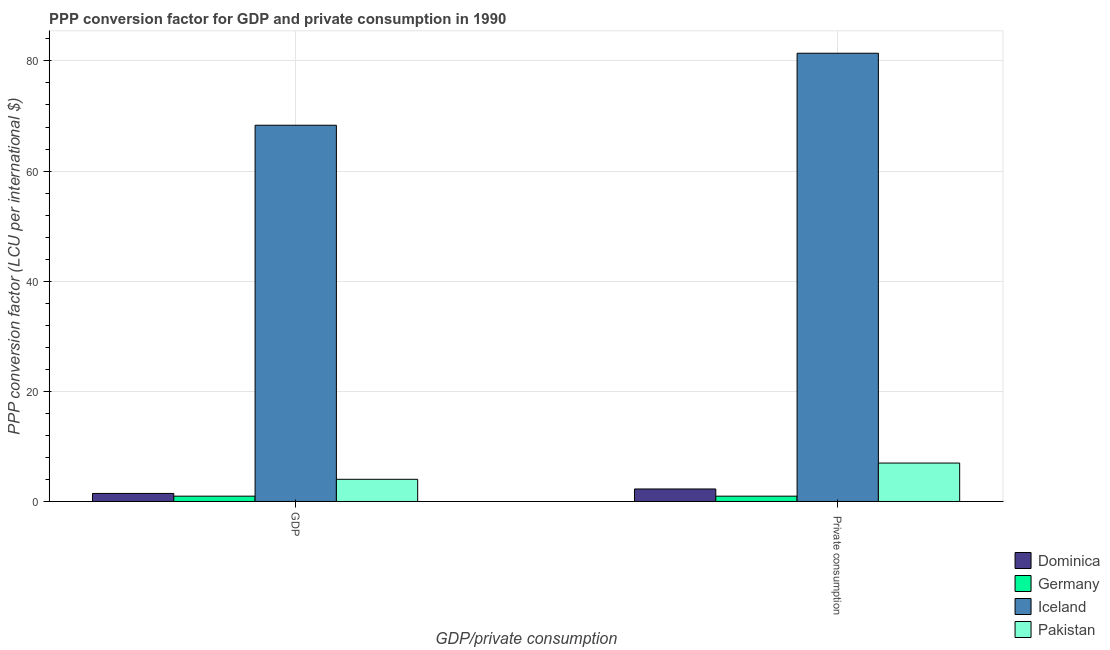How many groups of bars are there?
Keep it short and to the point. 2. What is the label of the 1st group of bars from the left?
Keep it short and to the point. GDP. What is the ppp conversion factor for gdp in Dominica?
Provide a short and direct response. 1.46. Across all countries, what is the maximum ppp conversion factor for gdp?
Ensure brevity in your answer.  68.32. Across all countries, what is the minimum ppp conversion factor for gdp?
Your response must be concise. 0.96. In which country was the ppp conversion factor for gdp maximum?
Offer a terse response. Iceland. In which country was the ppp conversion factor for private consumption minimum?
Ensure brevity in your answer.  Germany. What is the total ppp conversion factor for private consumption in the graph?
Give a very brief answer. 91.61. What is the difference between the ppp conversion factor for private consumption in Germany and that in Iceland?
Give a very brief answer. -80.43. What is the difference between the ppp conversion factor for gdp in Iceland and the ppp conversion factor for private consumption in Pakistan?
Ensure brevity in your answer.  61.34. What is the average ppp conversion factor for gdp per country?
Give a very brief answer. 18.69. What is the difference between the ppp conversion factor for gdp and ppp conversion factor for private consumption in Dominica?
Your answer should be compact. -0.81. What is the ratio of the ppp conversion factor for private consumption in Dominica to that in Iceland?
Provide a short and direct response. 0.03. Is the ppp conversion factor for gdp in Germany less than that in Pakistan?
Provide a short and direct response. Yes. What does the 3rd bar from the left in  Private consumption represents?
Your answer should be very brief. Iceland. How many countries are there in the graph?
Make the answer very short. 4. Does the graph contain any zero values?
Ensure brevity in your answer.  No. How many legend labels are there?
Your answer should be very brief. 4. How are the legend labels stacked?
Provide a short and direct response. Vertical. What is the title of the graph?
Make the answer very short. PPP conversion factor for GDP and private consumption in 1990. What is the label or title of the X-axis?
Your response must be concise. GDP/private consumption. What is the label or title of the Y-axis?
Ensure brevity in your answer.  PPP conversion factor (LCU per international $). What is the PPP conversion factor (LCU per international $) in Dominica in GDP?
Keep it short and to the point. 1.46. What is the PPP conversion factor (LCU per international $) of Germany in GDP?
Provide a short and direct response. 0.96. What is the PPP conversion factor (LCU per international $) of Iceland in GDP?
Keep it short and to the point. 68.32. What is the PPP conversion factor (LCU per international $) of Pakistan in GDP?
Make the answer very short. 4.03. What is the PPP conversion factor (LCU per international $) of Dominica in  Private consumption?
Give a very brief answer. 2.27. What is the PPP conversion factor (LCU per international $) of Germany in  Private consumption?
Your answer should be compact. 0.96. What is the PPP conversion factor (LCU per international $) of Iceland in  Private consumption?
Keep it short and to the point. 81.4. What is the PPP conversion factor (LCU per international $) in Pakistan in  Private consumption?
Make the answer very short. 6.98. Across all GDP/private consumption, what is the maximum PPP conversion factor (LCU per international $) of Dominica?
Offer a terse response. 2.27. Across all GDP/private consumption, what is the maximum PPP conversion factor (LCU per international $) of Germany?
Offer a very short reply. 0.96. Across all GDP/private consumption, what is the maximum PPP conversion factor (LCU per international $) of Iceland?
Offer a very short reply. 81.4. Across all GDP/private consumption, what is the maximum PPP conversion factor (LCU per international $) in Pakistan?
Make the answer very short. 6.98. Across all GDP/private consumption, what is the minimum PPP conversion factor (LCU per international $) in Dominica?
Ensure brevity in your answer.  1.46. Across all GDP/private consumption, what is the minimum PPP conversion factor (LCU per international $) of Germany?
Make the answer very short. 0.96. Across all GDP/private consumption, what is the minimum PPP conversion factor (LCU per international $) of Iceland?
Offer a very short reply. 68.32. Across all GDP/private consumption, what is the minimum PPP conversion factor (LCU per international $) of Pakistan?
Provide a succinct answer. 4.03. What is the total PPP conversion factor (LCU per international $) of Dominica in the graph?
Keep it short and to the point. 3.73. What is the total PPP conversion factor (LCU per international $) of Germany in the graph?
Give a very brief answer. 1.93. What is the total PPP conversion factor (LCU per international $) in Iceland in the graph?
Make the answer very short. 149.72. What is the total PPP conversion factor (LCU per international $) in Pakistan in the graph?
Keep it short and to the point. 11. What is the difference between the PPP conversion factor (LCU per international $) in Dominica in GDP and that in  Private consumption?
Your answer should be compact. -0.81. What is the difference between the PPP conversion factor (LCU per international $) of Germany in GDP and that in  Private consumption?
Give a very brief answer. -0. What is the difference between the PPP conversion factor (LCU per international $) in Iceland in GDP and that in  Private consumption?
Provide a short and direct response. -13.08. What is the difference between the PPP conversion factor (LCU per international $) of Pakistan in GDP and that in  Private consumption?
Provide a short and direct response. -2.95. What is the difference between the PPP conversion factor (LCU per international $) in Dominica in GDP and the PPP conversion factor (LCU per international $) in Germany in  Private consumption?
Ensure brevity in your answer.  0.49. What is the difference between the PPP conversion factor (LCU per international $) of Dominica in GDP and the PPP conversion factor (LCU per international $) of Iceland in  Private consumption?
Give a very brief answer. -79.94. What is the difference between the PPP conversion factor (LCU per international $) of Dominica in GDP and the PPP conversion factor (LCU per international $) of Pakistan in  Private consumption?
Keep it short and to the point. -5.52. What is the difference between the PPP conversion factor (LCU per international $) in Germany in GDP and the PPP conversion factor (LCU per international $) in Iceland in  Private consumption?
Offer a very short reply. -80.43. What is the difference between the PPP conversion factor (LCU per international $) of Germany in GDP and the PPP conversion factor (LCU per international $) of Pakistan in  Private consumption?
Keep it short and to the point. -6.01. What is the difference between the PPP conversion factor (LCU per international $) of Iceland in GDP and the PPP conversion factor (LCU per international $) of Pakistan in  Private consumption?
Your response must be concise. 61.34. What is the average PPP conversion factor (LCU per international $) in Dominica per GDP/private consumption?
Offer a very short reply. 1.86. What is the average PPP conversion factor (LCU per international $) of Germany per GDP/private consumption?
Offer a very short reply. 0.96. What is the average PPP conversion factor (LCU per international $) in Iceland per GDP/private consumption?
Give a very brief answer. 74.86. What is the average PPP conversion factor (LCU per international $) in Pakistan per GDP/private consumption?
Make the answer very short. 5.5. What is the difference between the PPP conversion factor (LCU per international $) of Dominica and PPP conversion factor (LCU per international $) of Germany in GDP?
Offer a very short reply. 0.49. What is the difference between the PPP conversion factor (LCU per international $) in Dominica and PPP conversion factor (LCU per international $) in Iceland in GDP?
Keep it short and to the point. -66.86. What is the difference between the PPP conversion factor (LCU per international $) of Dominica and PPP conversion factor (LCU per international $) of Pakistan in GDP?
Your response must be concise. -2.57. What is the difference between the PPP conversion factor (LCU per international $) of Germany and PPP conversion factor (LCU per international $) of Iceland in GDP?
Provide a short and direct response. -67.36. What is the difference between the PPP conversion factor (LCU per international $) of Germany and PPP conversion factor (LCU per international $) of Pakistan in GDP?
Give a very brief answer. -3.06. What is the difference between the PPP conversion factor (LCU per international $) of Iceland and PPP conversion factor (LCU per international $) of Pakistan in GDP?
Your answer should be very brief. 64.29. What is the difference between the PPP conversion factor (LCU per international $) in Dominica and PPP conversion factor (LCU per international $) in Germany in  Private consumption?
Your answer should be compact. 1.31. What is the difference between the PPP conversion factor (LCU per international $) in Dominica and PPP conversion factor (LCU per international $) in Iceland in  Private consumption?
Give a very brief answer. -79.13. What is the difference between the PPP conversion factor (LCU per international $) of Dominica and PPP conversion factor (LCU per international $) of Pakistan in  Private consumption?
Keep it short and to the point. -4.71. What is the difference between the PPP conversion factor (LCU per international $) of Germany and PPP conversion factor (LCU per international $) of Iceland in  Private consumption?
Your answer should be very brief. -80.43. What is the difference between the PPP conversion factor (LCU per international $) of Germany and PPP conversion factor (LCU per international $) of Pakistan in  Private consumption?
Provide a short and direct response. -6.01. What is the difference between the PPP conversion factor (LCU per international $) in Iceland and PPP conversion factor (LCU per international $) in Pakistan in  Private consumption?
Your answer should be very brief. 74.42. What is the ratio of the PPP conversion factor (LCU per international $) in Dominica in GDP to that in  Private consumption?
Your response must be concise. 0.64. What is the ratio of the PPP conversion factor (LCU per international $) in Germany in GDP to that in  Private consumption?
Your response must be concise. 1. What is the ratio of the PPP conversion factor (LCU per international $) of Iceland in GDP to that in  Private consumption?
Your answer should be very brief. 0.84. What is the ratio of the PPP conversion factor (LCU per international $) of Pakistan in GDP to that in  Private consumption?
Your answer should be very brief. 0.58. What is the difference between the highest and the second highest PPP conversion factor (LCU per international $) in Dominica?
Provide a succinct answer. 0.81. What is the difference between the highest and the second highest PPP conversion factor (LCU per international $) of Germany?
Your answer should be compact. 0. What is the difference between the highest and the second highest PPP conversion factor (LCU per international $) of Iceland?
Keep it short and to the point. 13.08. What is the difference between the highest and the second highest PPP conversion factor (LCU per international $) in Pakistan?
Your answer should be compact. 2.95. What is the difference between the highest and the lowest PPP conversion factor (LCU per international $) in Dominica?
Your answer should be compact. 0.81. What is the difference between the highest and the lowest PPP conversion factor (LCU per international $) of Germany?
Your response must be concise. 0. What is the difference between the highest and the lowest PPP conversion factor (LCU per international $) in Iceland?
Offer a very short reply. 13.08. What is the difference between the highest and the lowest PPP conversion factor (LCU per international $) in Pakistan?
Offer a terse response. 2.95. 